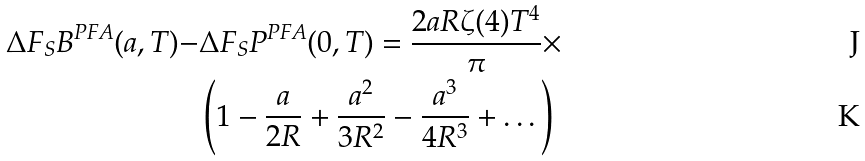Convert formula to latex. <formula><loc_0><loc_0><loc_500><loc_500>\Delta F _ { S } B ^ { P F A } ( a , T ) - & \Delta F _ { S } P ^ { P F A } ( 0 , T ) = \frac { 2 a R \zeta ( 4 ) T ^ { 4 } } { \pi } \times \\ & \left ( 1 - \frac { a } { 2 R } + \frac { a ^ { 2 } } { 3 R ^ { 2 } } - \frac { a ^ { 3 } } { 4 R ^ { 3 } } + \dots \right )</formula> 